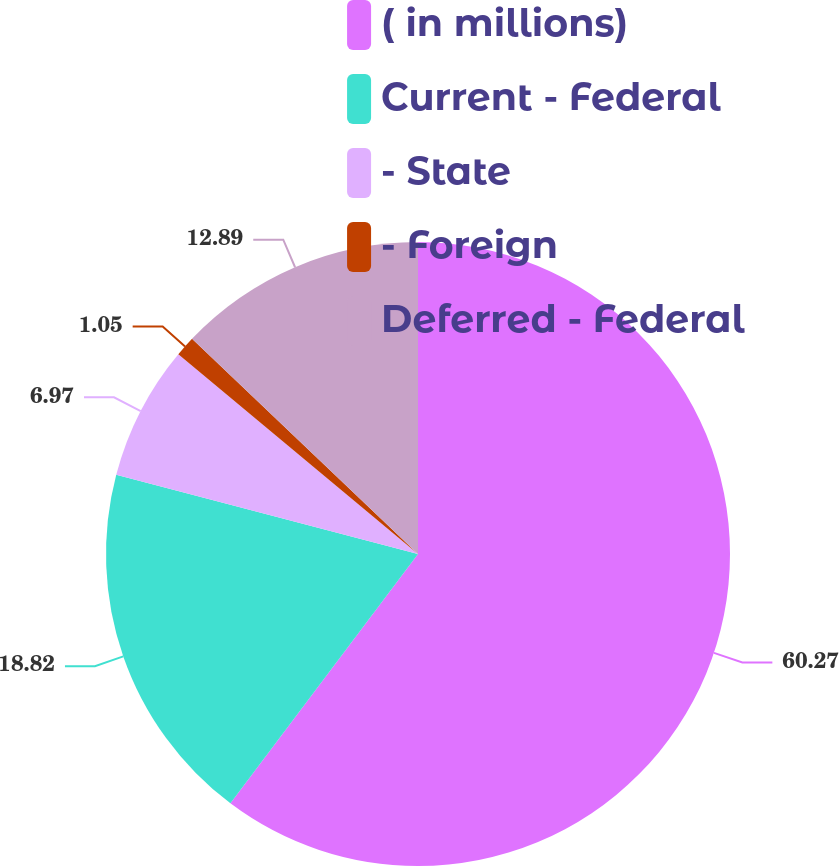Convert chart. <chart><loc_0><loc_0><loc_500><loc_500><pie_chart><fcel>( in millions)<fcel>Current - Federal<fcel>- State<fcel>- Foreign<fcel>Deferred - Federal<nl><fcel>60.26%<fcel>18.82%<fcel>6.97%<fcel>1.05%<fcel>12.89%<nl></chart> 